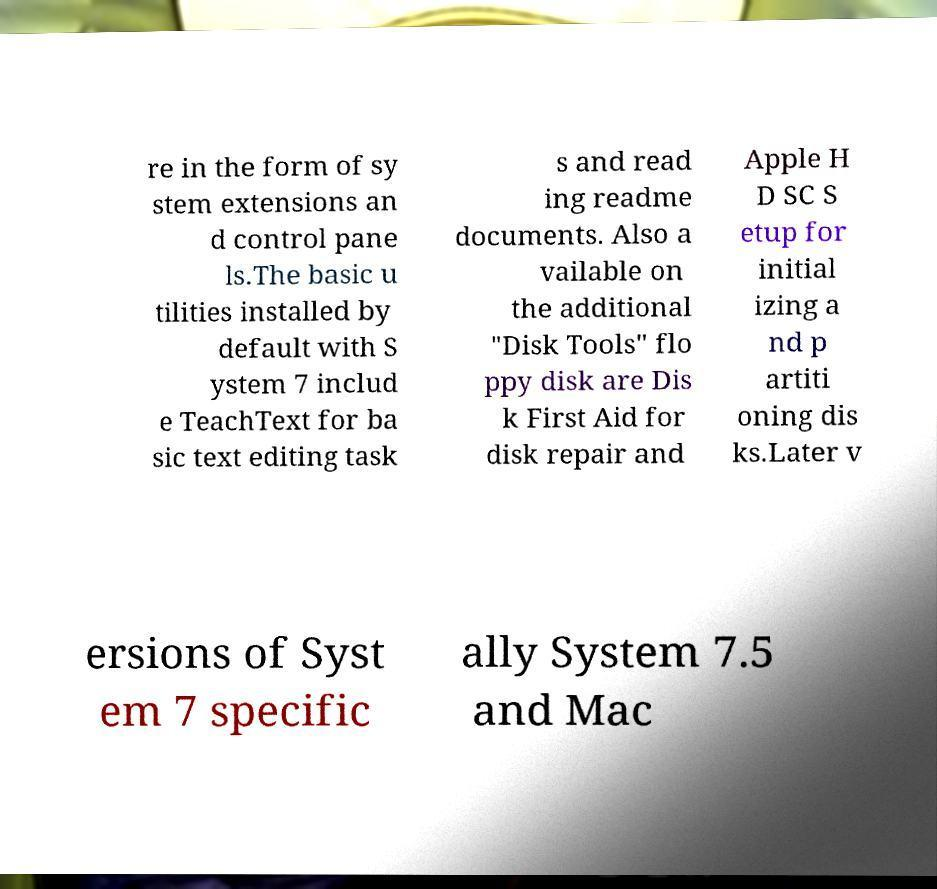Can you accurately transcribe the text from the provided image for me? re in the form of sy stem extensions an d control pane ls.The basic u tilities installed by default with S ystem 7 includ e TeachText for ba sic text editing task s and read ing readme documents. Also a vailable on the additional "Disk Tools" flo ppy disk are Dis k First Aid for disk repair and Apple H D SC S etup for initial izing a nd p artiti oning dis ks.Later v ersions of Syst em 7 specific ally System 7.5 and Mac 